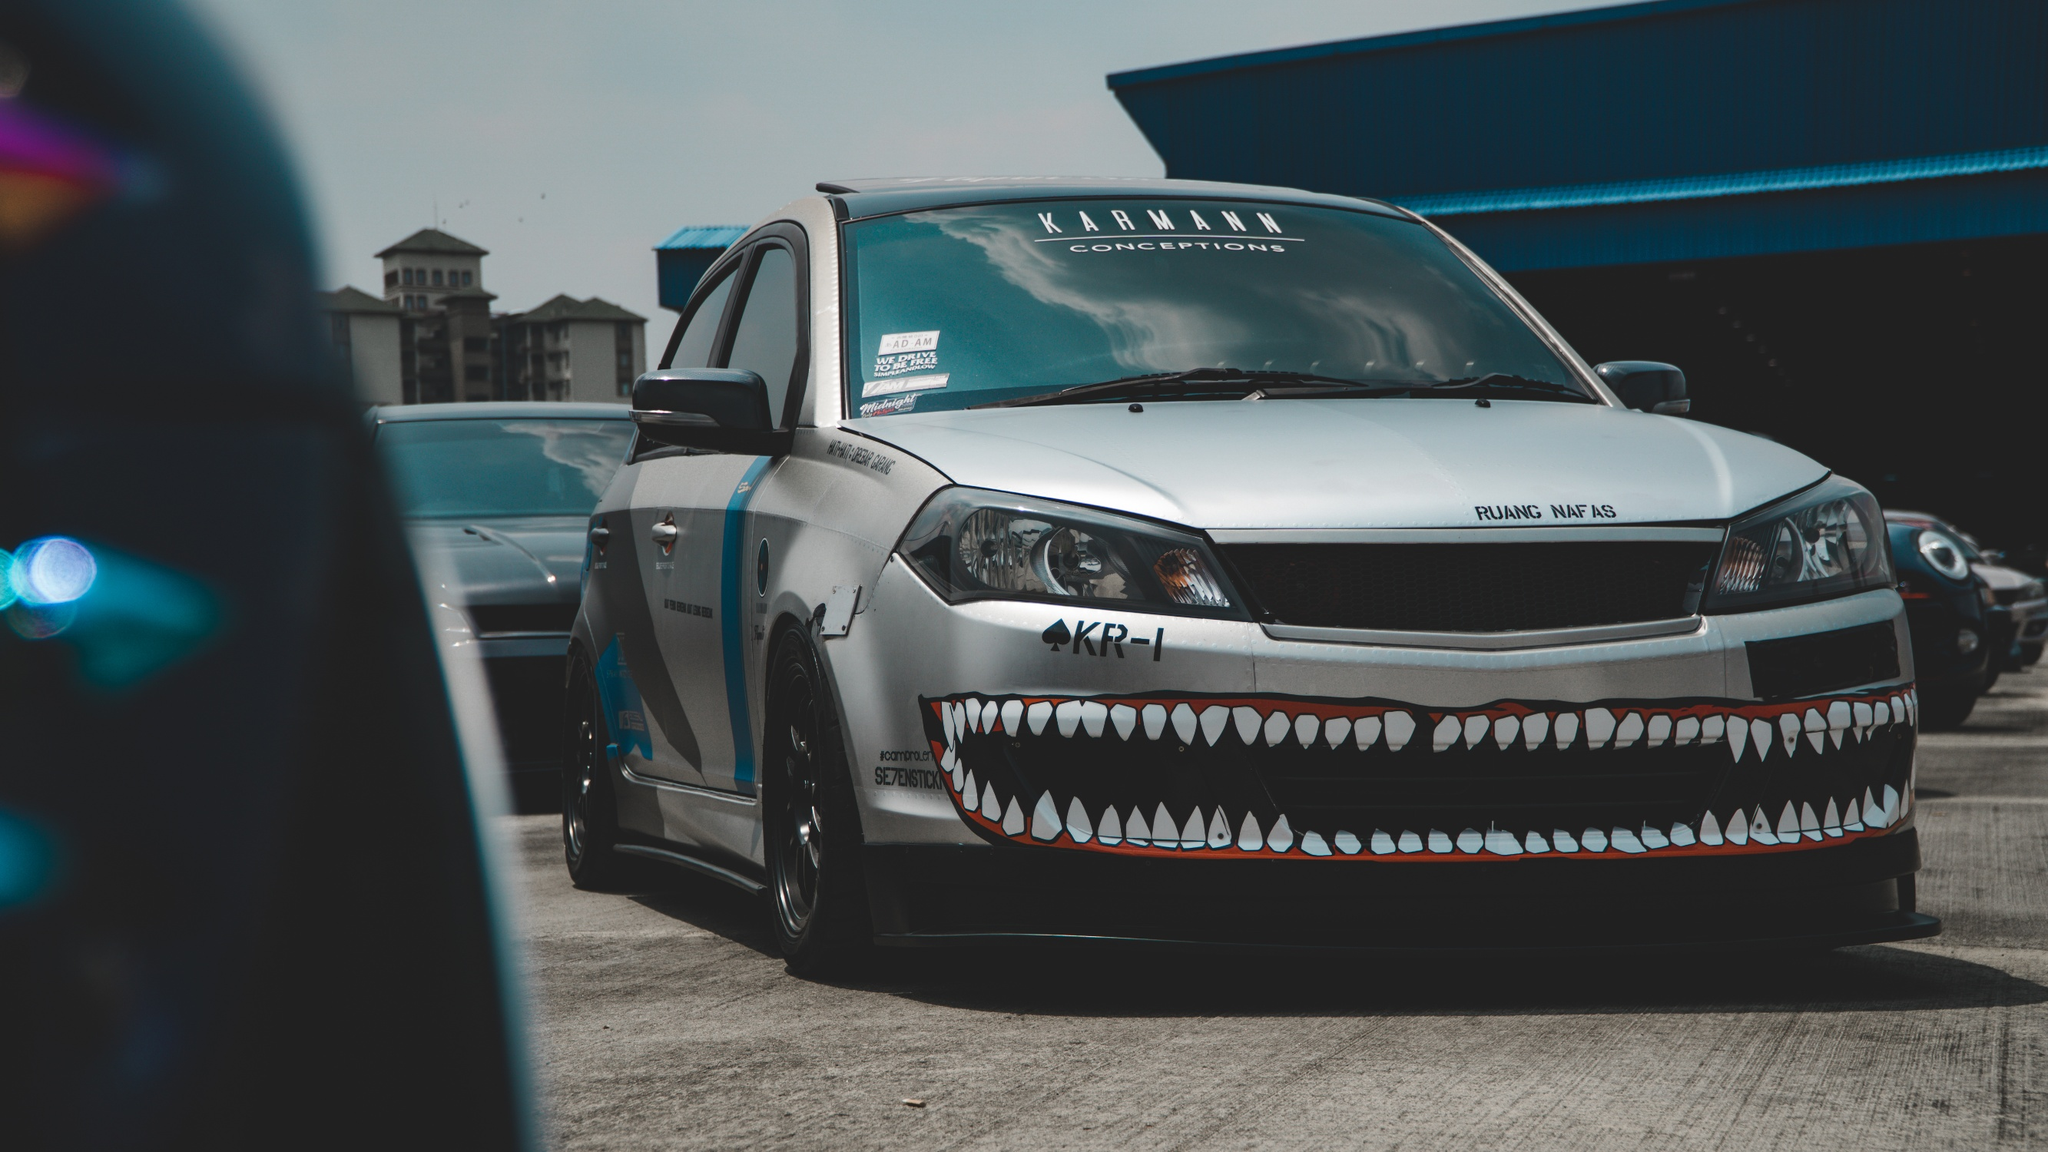Could you describe the car's design in more detail? Absolutely! The car in the image boasts a striking design that immediately captures the eye. The body of the car is predominantly white with a contrasting black hood, giving it a sophisticated yet bold appearance. The most remarkable feature, however, is the front bumper, which is uniquely decorated with sharp, menacing teeth that resemble a shark's snarling mouth. This aggressive design gives the car a distinctive, custom look that sets it apart from the other vehicles in the lot. The side of the car features a blue stripe running from the front to the back, adding a touch of color to the overall monochromatic theme. The car's windows are tinted, and stickers adorn the windshield, hinting at a personalized touch by the owner. Overall, the car’s design is a blend of creativity and audacity, making it a true standout. 